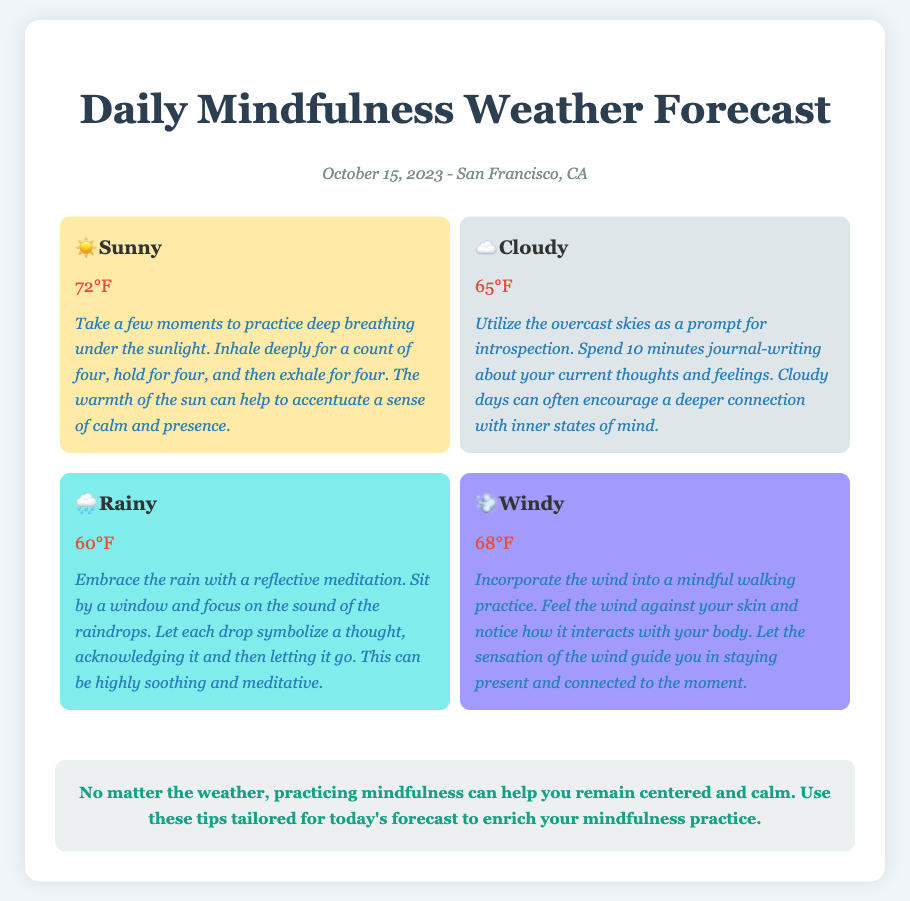What is the date of the forecast? The date of the forecast is mentioned in the document as October 15, 2023.
Answer: October 15, 2023 What is the temperature on a rainy day? The temperature for the rainy day condition is provided in the document, which is 60°F.
Answer: 60°F What mindfulness tip is suggested for a windy day? The document contains a specific mindfulness tip for windy days, which involves mindful walking.
Answer: Mindful walking How many weather conditions are detailed in the report? The document lists four different weather conditions, which can be counted from the forecast section.
Answer: Four Which weather condition has the warmest temperature? The sunny condition’s temperature is the highest at 72°F according to the document.
Answer: 72°F What mindfulness practice is advised for cloudy days? The report includes a suggestion for introspection through journaling on cloudy days.
Answer: Journal-writing What color is used for the rainy day forecast item? The background color for the rainy day forecast item is specified in the document as #81ecec.
Answer: #81ecec What is the overall reminder given at the end of the report? The reminder emphasizes practicing mindfulness regardless of the weather, as stated in the document.
Answer: Remain centered and calm 